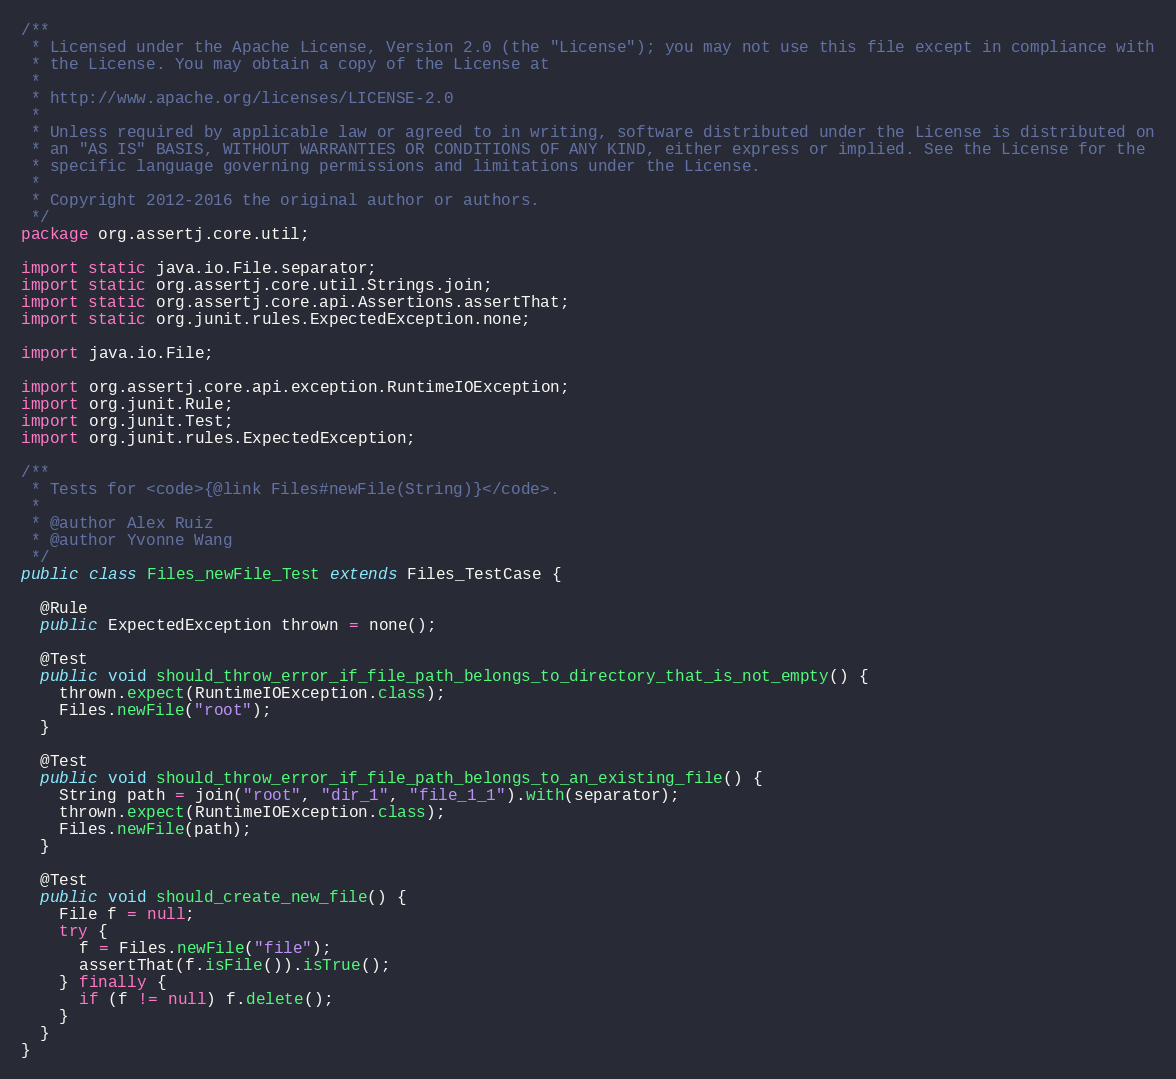<code> <loc_0><loc_0><loc_500><loc_500><_Java_>/**
 * Licensed under the Apache License, Version 2.0 (the "License"); you may not use this file except in compliance with
 * the License. You may obtain a copy of the License at
 *
 * http://www.apache.org/licenses/LICENSE-2.0
 *
 * Unless required by applicable law or agreed to in writing, software distributed under the License is distributed on
 * an "AS IS" BASIS, WITHOUT WARRANTIES OR CONDITIONS OF ANY KIND, either express or implied. See the License for the
 * specific language governing permissions and limitations under the License.
 *
 * Copyright 2012-2016 the original author or authors.
 */
package org.assertj.core.util;

import static java.io.File.separator;
import static org.assertj.core.util.Strings.join;
import static org.assertj.core.api.Assertions.assertThat;
import static org.junit.rules.ExpectedException.none;

import java.io.File;

import org.assertj.core.api.exception.RuntimeIOException;
import org.junit.Rule;
import org.junit.Test;
import org.junit.rules.ExpectedException;

/**
 * Tests for <code>{@link Files#newFile(String)}</code>.
 * 
 * @author Alex Ruiz
 * @author Yvonne Wang
 */
public class Files_newFile_Test extends Files_TestCase {

  @Rule
  public ExpectedException thrown = none();

  @Test
  public void should_throw_error_if_file_path_belongs_to_directory_that_is_not_empty() {
    thrown.expect(RuntimeIOException.class);
    Files.newFile("root");
  }

  @Test
  public void should_throw_error_if_file_path_belongs_to_an_existing_file() {
    String path = join("root", "dir_1", "file_1_1").with(separator);
    thrown.expect(RuntimeIOException.class);
    Files.newFile(path);
  }

  @Test
  public void should_create_new_file() {
    File f = null;
    try {
      f = Files.newFile("file");
      assertThat(f.isFile()).isTrue();
    } finally {
      if (f != null) f.delete();
    }
  }
}
</code> 